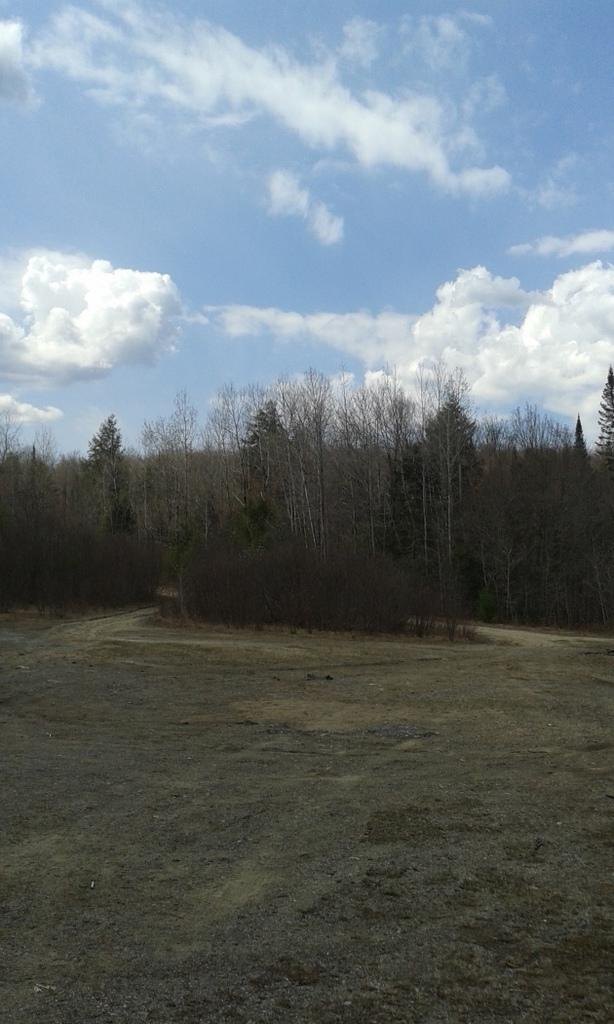What type of vegetation is present in the image? There is grass in the image. What other natural elements can be seen in the image? There are trees in the image. What part of the natural environment is visible in the background of the image? The sky is visible in the background of the image. What type of map can be seen in the image? There is no map present in the image; it features grass, trees, and the sky. What boundary is visible in the image? There is no boundary visible in the image; it features natural elements such as grass, trees, and the sky. 